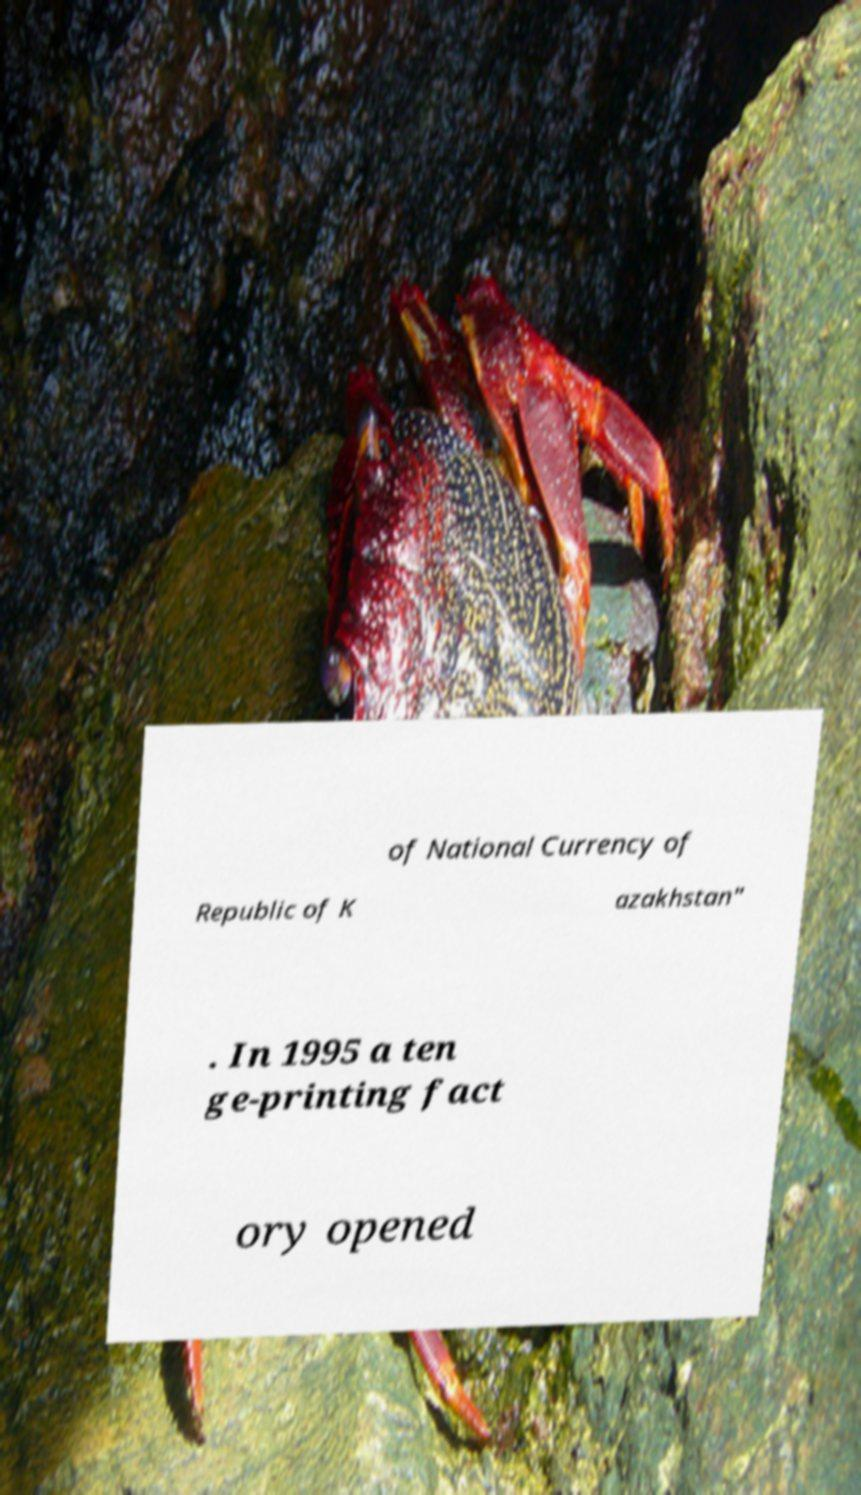Could you assist in decoding the text presented in this image and type it out clearly? of National Currency of Republic of K azakhstan" . In 1995 a ten ge-printing fact ory opened 